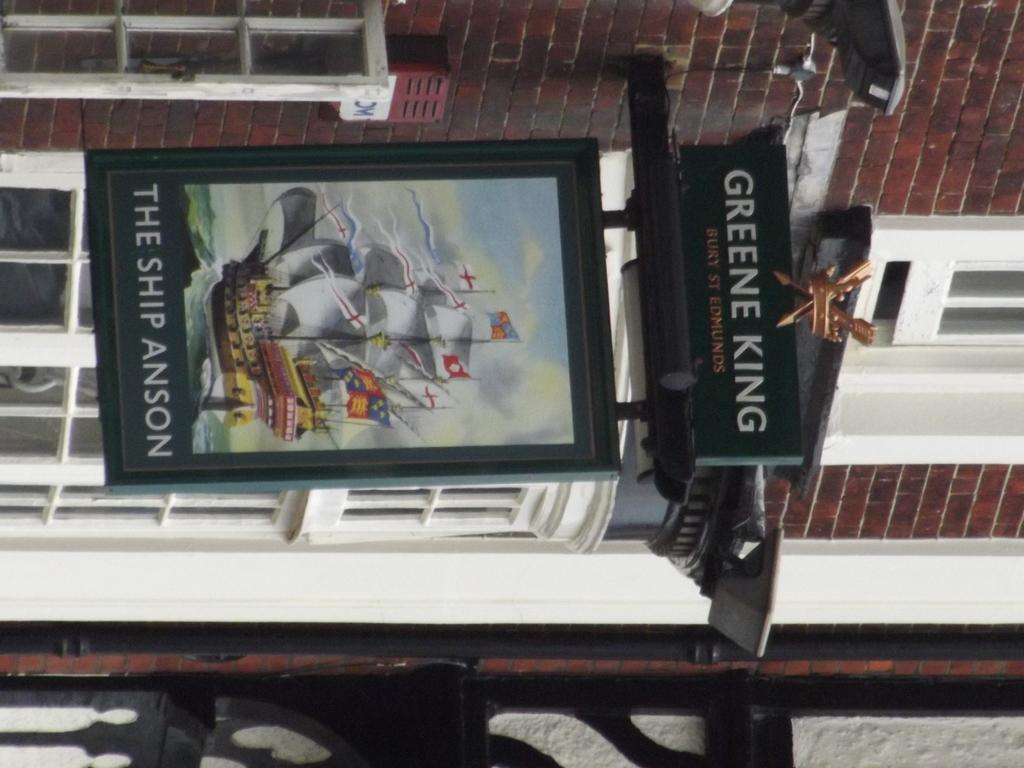<image>
Create a compact narrative representing the image presented. A sign with a ship image is displayed outside a building with the name The Ship Anson. 